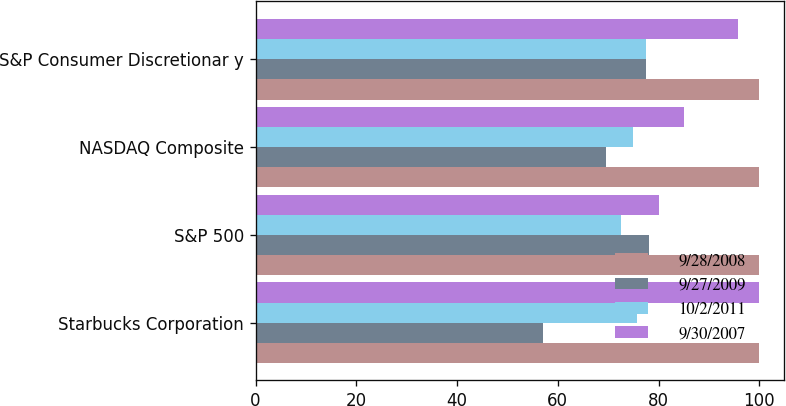<chart> <loc_0><loc_0><loc_500><loc_500><stacked_bar_chart><ecel><fcel>Starbucks Corporation<fcel>S&P 500<fcel>NASDAQ Composite<fcel>S&P Consumer Discretionar y<nl><fcel>9/28/2008<fcel>100<fcel>100<fcel>100<fcel>100<nl><fcel>9/27/2009<fcel>57.1<fcel>78.02<fcel>69.59<fcel>77.59<nl><fcel>10/2/2011<fcel>75.69<fcel>72.63<fcel>74.9<fcel>77.55<nl><fcel>9/30/2007<fcel>99.93<fcel>80.01<fcel>84.99<fcel>95.87<nl></chart> 